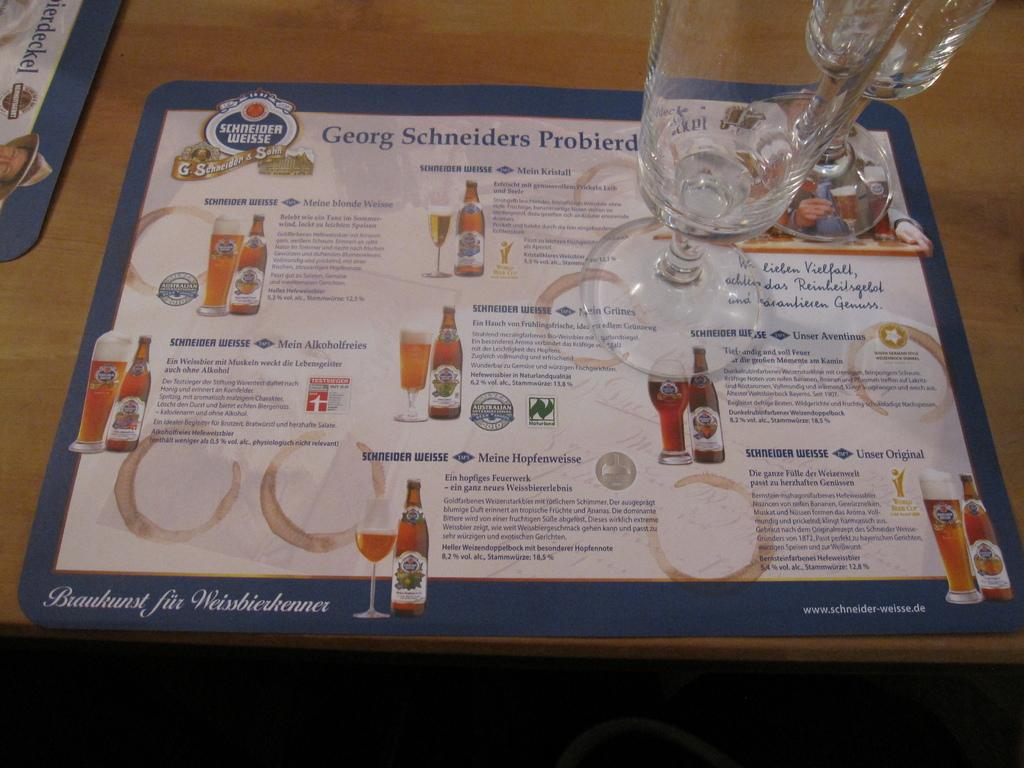Provide a one-sentence caption for the provided image. A place mat menu of different types of ales by Schneider Weisse. 